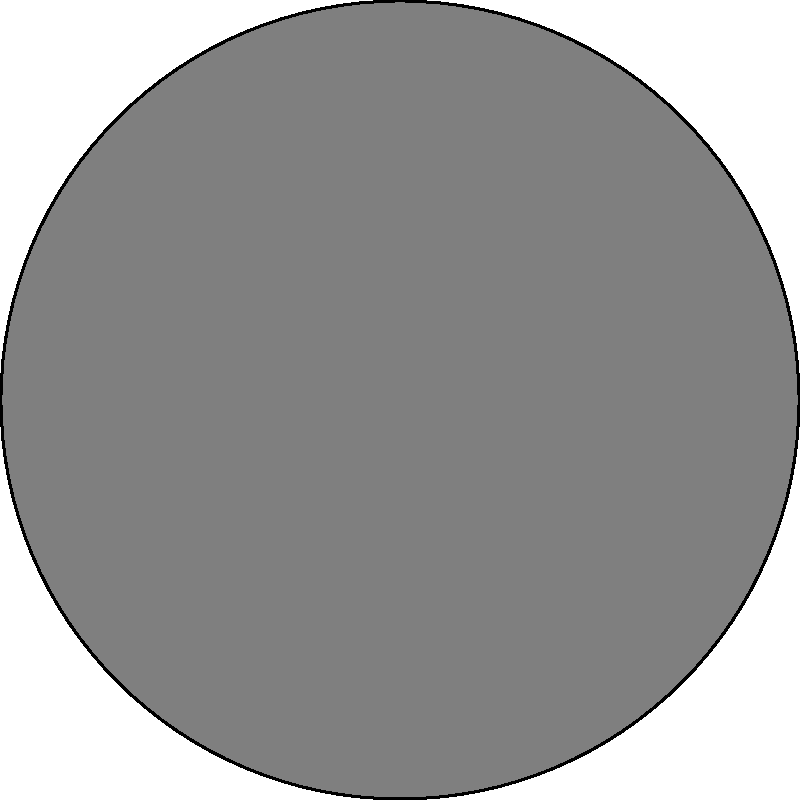As a horse breeder lifting heavy hay bales for your Belgian draft horses, you're considering two pulley systems to make the task easier. System A uses a single fixed pulley, while System B uses a single movable pulley. Both systems are designed to lift a 1000 kg hay bale. Which system requires less force to lift the bale, and what is the mechanical advantage of that system? To determine which system requires less force and its mechanical advantage, let's analyze each system:

1. System A (Single Fixed Pulley):
   - A fixed pulley only changes the direction of the force, not its magnitude.
   - Mechanical Advantage (MA) = $\frac{\text{Load}}{\text{Effort}} = 1$
   - Force required = Weight of the load = 1000 kg × 9.8 m/s² = 9800 N

2. System B (Single Movable Pulley):
   - A movable pulley distributes the weight between two rope sections.
   - Mechanical Advantage (MA) = $\frac{\text{Load}}{\text{Effort}} = 2$
   - Force required = $\frac{\text{Weight of the load}}{2} = \frac{9800 \text{ N}}{2} = 4900 \text{ N}$

3. Comparison:
   - System B requires less force (4900 N) compared to System A (9800 N).
   - System B has a higher mechanical advantage (MA = 2) than System A (MA = 1).

Therefore, System B (single movable pulley) requires less force to lift the hay bale and has a mechanical advantage of 2.
Answer: System B; MA = 2 